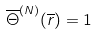Convert formula to latex. <formula><loc_0><loc_0><loc_500><loc_500>\overline { \Theta } ^ { ( N ) } ( \overline { r } ) = 1</formula> 